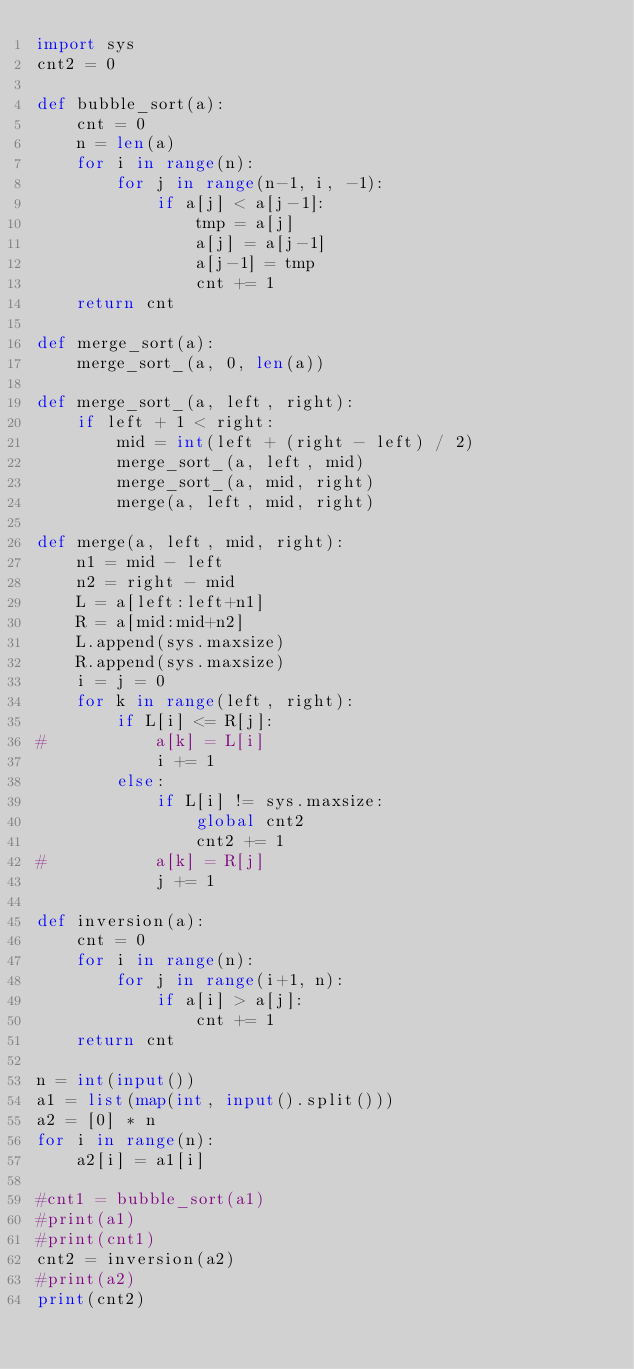Convert code to text. <code><loc_0><loc_0><loc_500><loc_500><_Python_>import sys
cnt2 = 0

def bubble_sort(a):
	cnt = 0
	n = len(a)
	for i in range(n):
		for j in range(n-1, i, -1):
			if a[j] < a[j-1]:
				tmp = a[j]
				a[j] = a[j-1]
				a[j-1] = tmp
				cnt += 1
	return cnt

def merge_sort(a):
	merge_sort_(a, 0, len(a))

def merge_sort_(a, left, right):
	if left + 1 < right:
		mid = int(left + (right - left) / 2)
		merge_sort_(a, left, mid)
		merge_sort_(a, mid, right)
		merge(a, left, mid, right)

def merge(a, left, mid, right):
	n1 = mid - left
	n2 = right - mid
	L = a[left:left+n1]
	R = a[mid:mid+n2]
	L.append(sys.maxsize)
	R.append(sys.maxsize)
	i = j = 0
	for k in range(left, right):
		if L[i] <= R[j]:
#			a[k] = L[i]
			i += 1
		else:
			if L[i] != sys.maxsize:
				global cnt2
				cnt2 += 1
#			a[k] = R[j]
			j += 1

def inversion(a):
	cnt = 0
	for i in range(n):
		for j in range(i+1, n):
			if a[i] > a[j]:
				cnt += 1
	return cnt
	
n = int(input())
a1 = list(map(int, input().split()))
a2 = [0] * n
for i in range(n):
	a2[i] = a1[i]

#cnt1 = bubble_sort(a1)
#print(a1)
#print(cnt1)
cnt2 = inversion(a2)
#print(a2)
print(cnt2)

</code> 